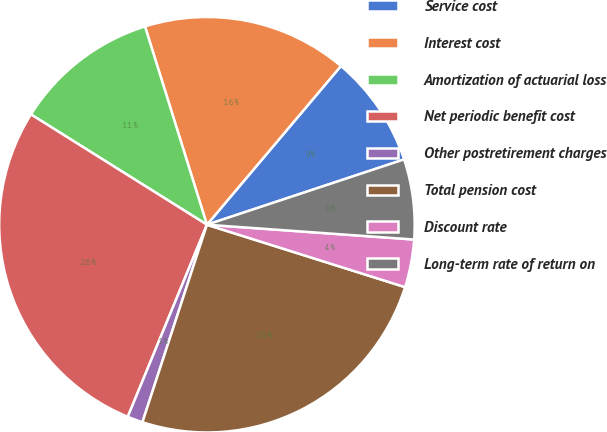<chart> <loc_0><loc_0><loc_500><loc_500><pie_chart><fcel>Service cost<fcel>Interest cost<fcel>Amortization of actuarial loss<fcel>Net periodic benefit cost<fcel>Other postretirement charges<fcel>Total pension cost<fcel>Discount rate<fcel>Long-term rate of return on<nl><fcel>8.75%<fcel>15.98%<fcel>11.27%<fcel>27.69%<fcel>1.2%<fcel>25.17%<fcel>3.72%<fcel>6.23%<nl></chart> 